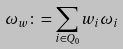Convert formula to latex. <formula><loc_0><loc_0><loc_500><loc_500>\omega _ { w } \colon = \sum _ { i \in Q _ { 0 } } w _ { i } \omega _ { i }</formula> 